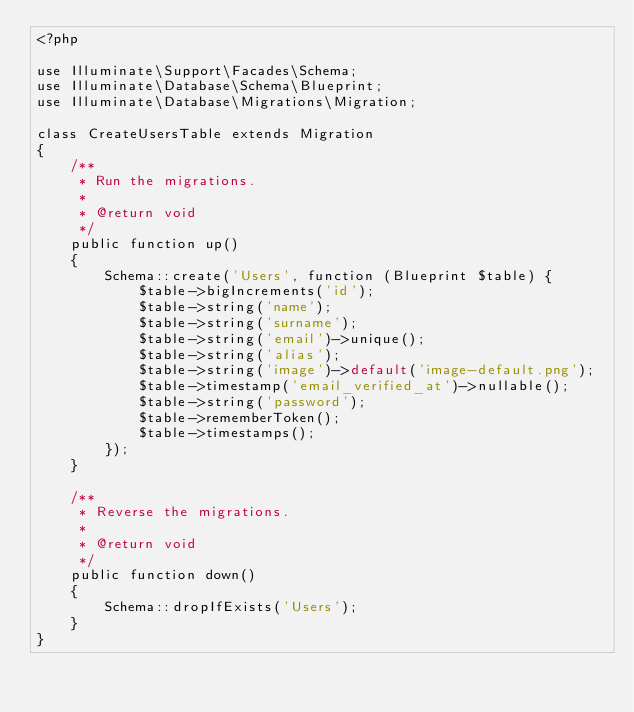<code> <loc_0><loc_0><loc_500><loc_500><_PHP_><?php

use Illuminate\Support\Facades\Schema;
use Illuminate\Database\Schema\Blueprint;
use Illuminate\Database\Migrations\Migration;

class CreateUsersTable extends Migration
{
    /**
     * Run the migrations.
     *
     * @return void
     */
    public function up()
    {
        Schema::create('Users', function (Blueprint $table) {
            $table->bigIncrements('id');
            $table->string('name');
            $table->string('surname');
            $table->string('email')->unique();
            $table->string('alias');
            $table->string('image')->default('image-default.png');
            $table->timestamp('email_verified_at')->nullable();
            $table->string('password');
            $table->rememberToken();
            $table->timestamps();
        });
    }

    /**
     * Reverse the migrations.
     *
     * @return void
     */
    public function down()
    {
        Schema::dropIfExists('Users');
    }
}
</code> 